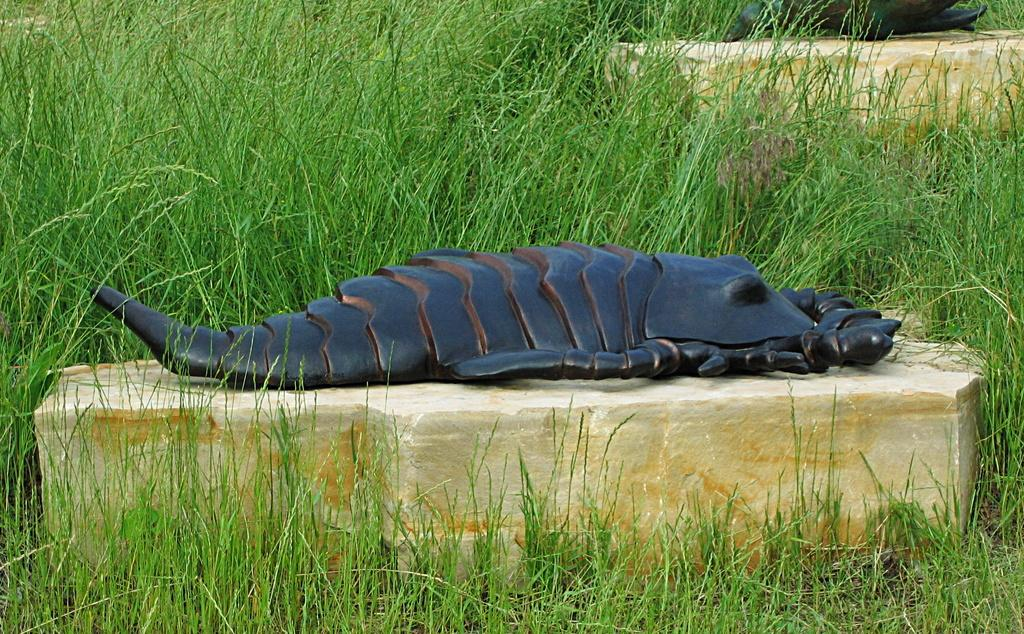What is the subject of the statue in the image? The statue in the image is of a Scorpio. Where is the statue positioned in the image? The statue is placed on a rock. What type of vegetation is present around the statue? There is grass around the statue. How many laborers are working on the statue in the image? There are no laborers present in the image, as it only features a statue of a Scorpio placed on a rock with grass around it. 